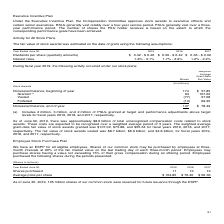According to Microsoft Corporation's financial document, How much were the total unrecognized compensation costs related to stock awards as of June 30, 2019? As of June 30, 2019, there was approximately $8.6 billion of total unrecognized compensation costs related to stock awards.. The document states: "As of June 30, 2019, there was approximately $8.6 billion of total unrecognized compensation costs related to stock awards. These costs are expected t..." Also, What did the granted stock awards include? (a) Includes 2 million, 3 million, and 2 million of PSUs granted at target and performance adjustments above target levels for fiscal years 2019, 2018, and 2017, respectively.. The document states: "(a) Includes 2 million, 3 million, and 2 million of PSUs granted at target and performance adjustments above target levels for fiscal years 2019, 2018..." Also, What was the fair value of stock awards vested for 2017? The fair value of stock awards vested was $8.7 billion, $6.6 billion, and $4.8 billion, for fiscal years 2019, 2018, and 2017, respectively.. The document states: "r fiscal years 2019, 2018, and 2017, respectively. The fair value of stock awards vested was $8.7 billion, $6.6 billion, and $4.8 billion, for fiscal ..." Also, How many items affect the nonvested balance? Counting the relevant items in the document: Granted, vested, forfeited, I find 3 instances. The key data points involved are: Granted, forfeited, vested. Also, can you calculate: What was the number of stock awards that were granted in 2019, not including the PSUs granted? Based on the calculation: 63-2 , the result is 61 (in millions). This is based on the information: "Granted (a) 63 107.02 Granted (a) 63 107.02..." The key data points involved are: 2, 63. Also, can you calculate: What was the average fair value of stock awards vested over the 3 year period from 2017 to 2019? To answer this question, I need to perform calculations using the financial data. The calculation is: (8.7+6.6+4.8)/3, which equals 6.7 (in billions). This is based on the information: "wards vested was $8.7 billion, $6.6 billion, and $4.8 billion, for fiscal years 2019, 2018, and 2017, respectively. ively. The fair value of stock awards vested was $8.7 billion, $6.6 billion, and $4...." The key data points involved are: 4.8, 6.6, 8.7. 